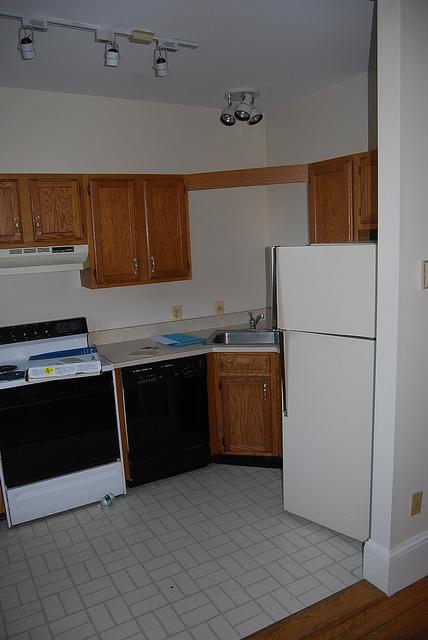Are the lights on?
Answer briefly. No. How many microwaves are in the picture?
Quick response, please. 0. What kind of room is this?
Concise answer only. Kitchen. What fuels this stove?
Write a very short answer. Gas. Is the white appliance in the photo in current use?
Answer briefly. Yes. Where is the location?
Quick response, please. Kitchen. Is there a coffee pot?
Keep it brief. No. What is on the refrigerator?
Answer briefly. Nothing. What room is this?
Quick response, please. Kitchen. Are there any stainless steel appliances?
Concise answer only. No. Are there any items on top of the stove?
Write a very short answer. Yes. Does the cupboard have a glass door?
Keep it brief. No. What color are the baseboards?
Answer briefly. White. Is that a dishwasher?
Give a very brief answer. Yes. What is on the floor?
Keep it brief. Tile. Is someone installing a backsplash?
Give a very brief answer. No. Does this room have tripping hazards?
Give a very brief answer. No. Are there any magnets on the refrigerator?
Keep it brief. No. Is the fridge new?
Short answer required. No. What color are the kitchen cabinets?
Concise answer only. Brown. Are these appliance new?
Give a very brief answer. No. Is this refrigerator running?
Short answer required. Yes. Is there anything on the refrigerator door?
Short answer required. No. Is this a picture of a studio apartment?
Be succinct. No. Does this look like a large room?
Keep it brief. No. What color is the floor?
Short answer required. White. Is there an ice maker on the fridge door?
Keep it brief. No. What color are the appliances?
Keep it brief. White. Is the refrigerator door open?
Write a very short answer. No. How many lights are on the ceiling?
Short answer required. 6. Is the light on?
Answer briefly. No. What appliance is to the right of the stove?
Quick response, please. Dishwasher. Is there a reflection on the refrigerator?
Answer briefly. No. Does it look like the homeowner forgot to measure the height of the refrigerator?
Short answer required. Yes. Would a claustrophobic person like this room?
Concise answer only. No. How many pictures are there?
Be succinct. 0. 